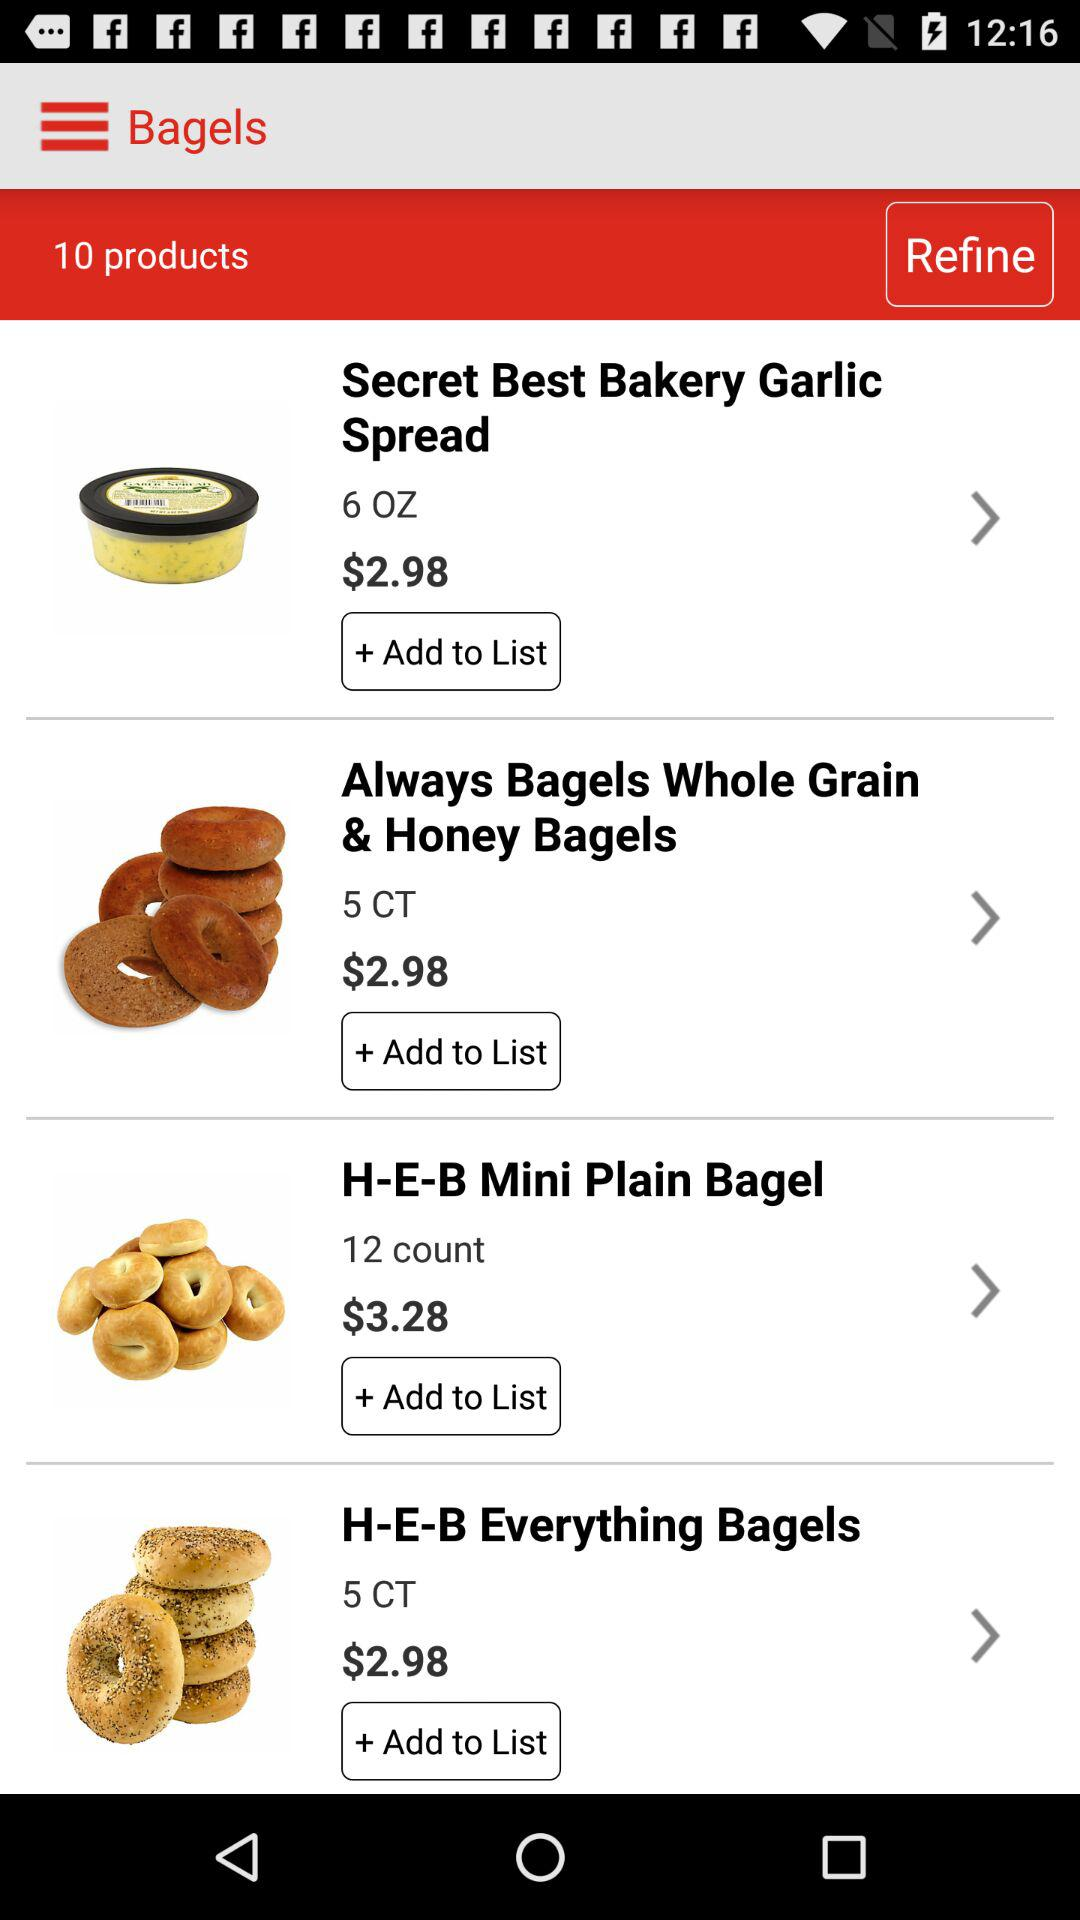How many items are priced at $2.98?
Answer the question using a single word or phrase. 3 